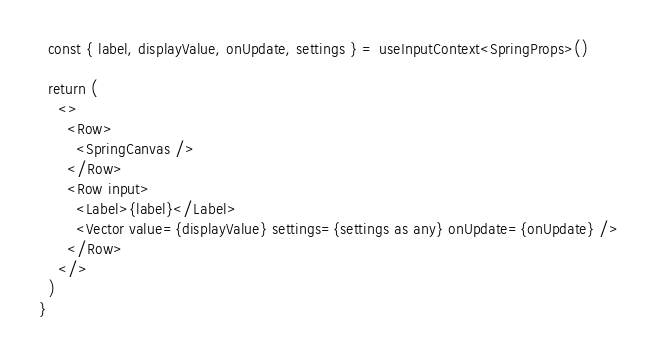Convert code to text. <code><loc_0><loc_0><loc_500><loc_500><_TypeScript_>  const { label, displayValue, onUpdate, settings } = useInputContext<SpringProps>()

  return (
    <>
      <Row>
        <SpringCanvas />
      </Row>
      <Row input>
        <Label>{label}</Label>
        <Vector value={displayValue} settings={settings as any} onUpdate={onUpdate} />
      </Row>
    </>
  )
}
</code> 